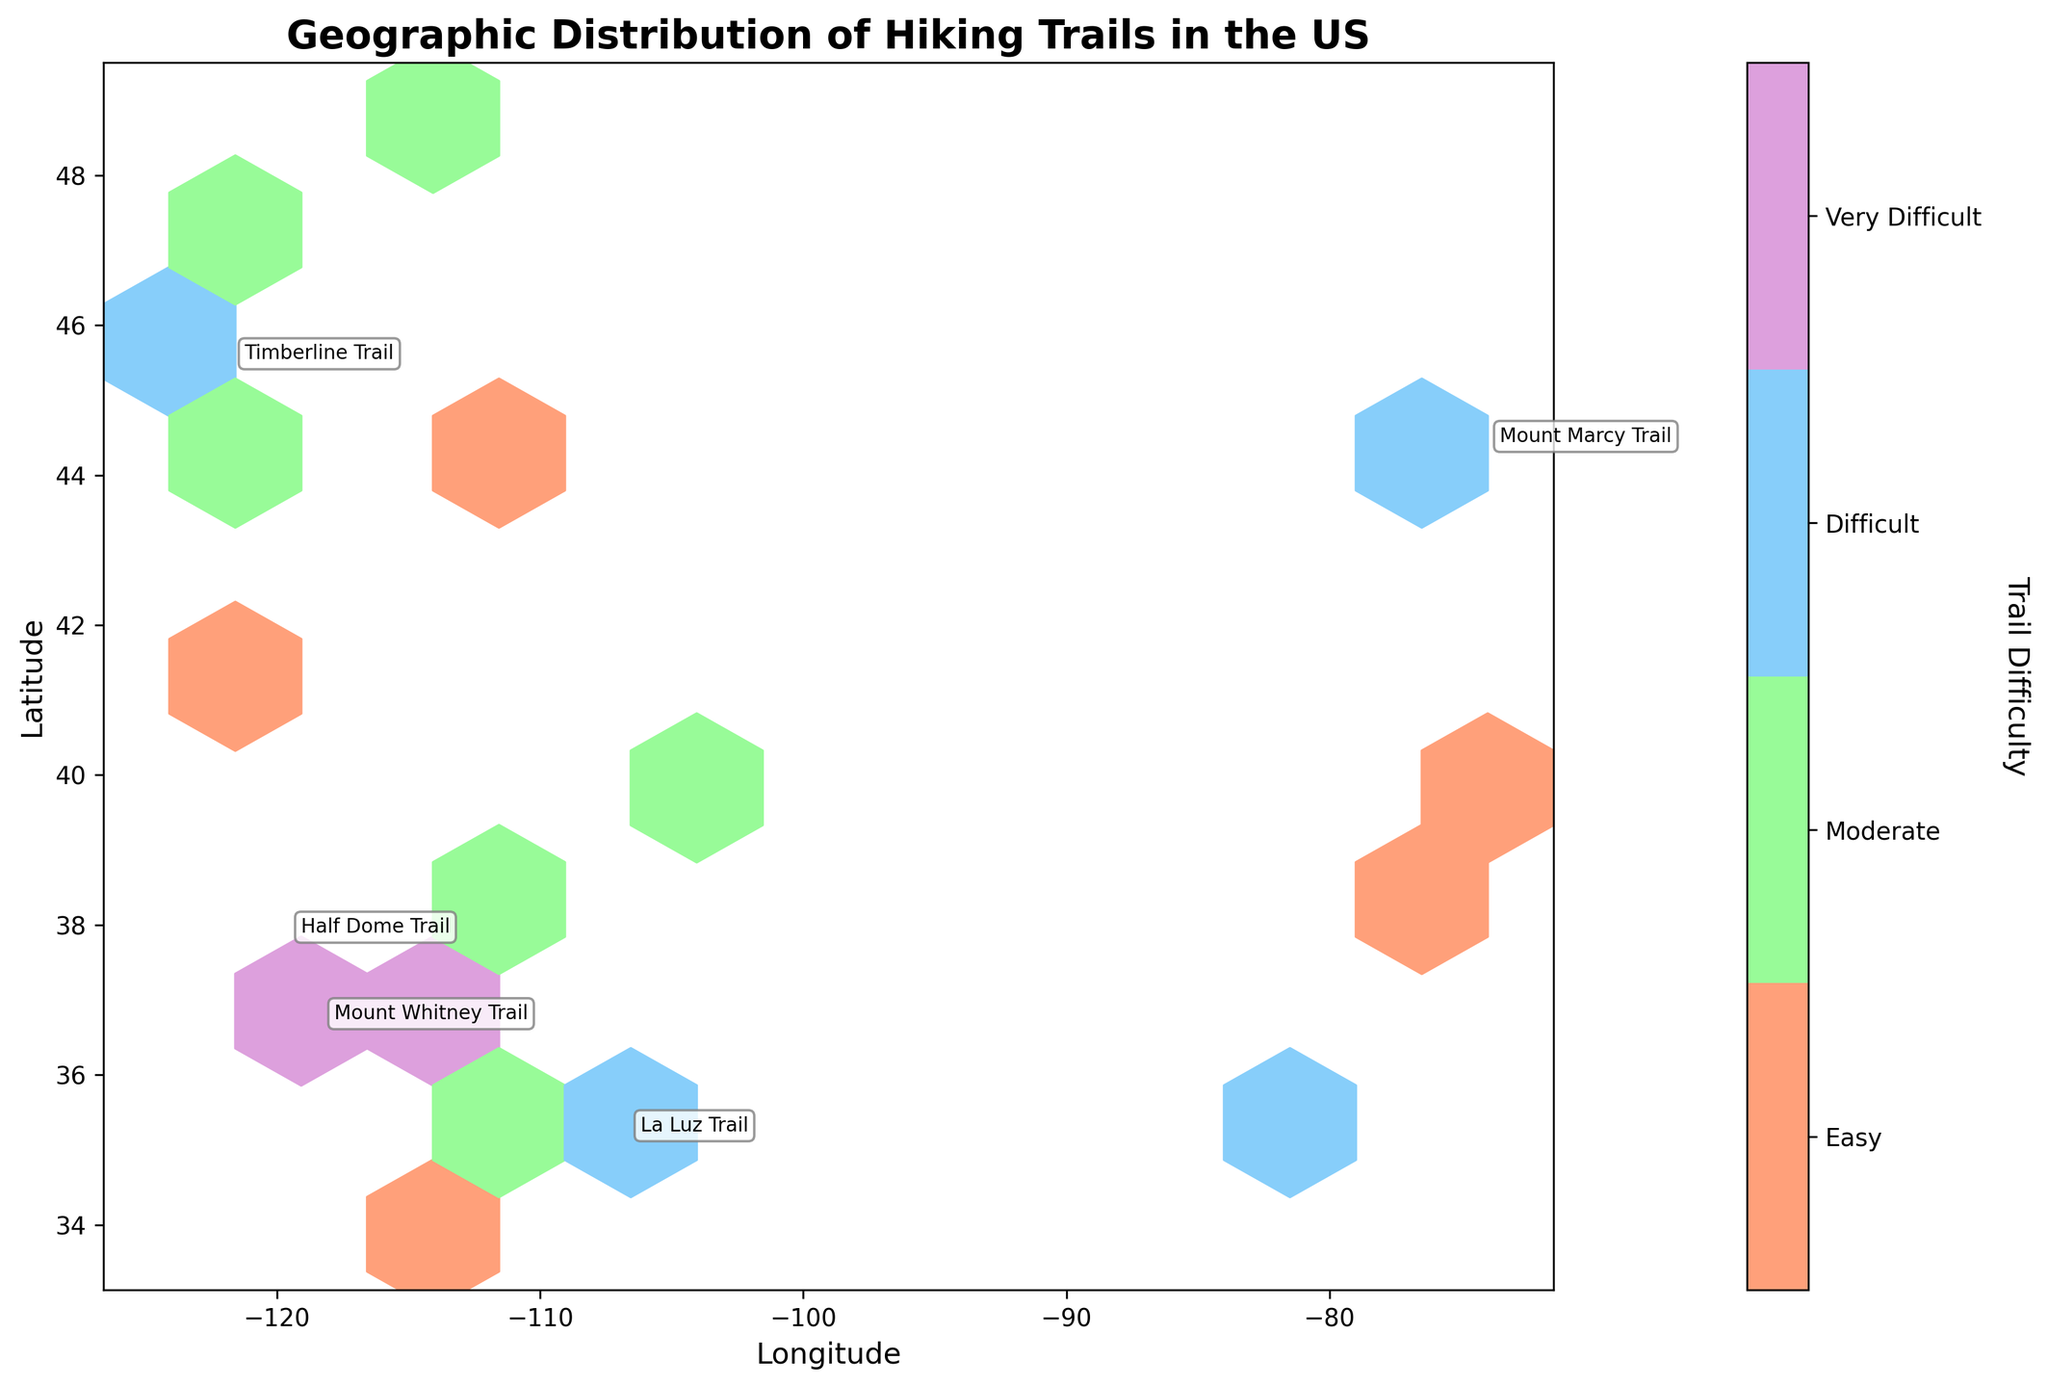What is the title of the plot? The plot’s title is located at the top center of the figure, displayed in a bold format. It reads "Geographic Distribution of Hiking Trails in the US".
Answer: Geographic Distribution of Hiking Trails in the US How are trail difficulties represented in the plot? Trail difficulties are represented by different colors in the plot. According to the color bar on the right, 'Easy' trails are in light orange, 'Moderate' trails are in light green, 'Difficult' trails are in light blue, and 'Very Difficult' trails are in light purple.
Answer: By different colors Which axis represents Longitude? Longitude is displayed on the horizontal axis at the bottom of the figure, labeled as 'Longitude'.
Answer: Horizontal axis Which sections of the US have the most trails with large elevation changes? By examining the annotations and color distribution, we notice clusters of 'Very Difficult' (purple) and 'Difficult' (blue) trails. These are most frequent in the western US, particularly around the Pacific Northwest and central California regions.
Answer: Western US What regions are annotated, and why were they chosen? The annotated regions are those with substantial elevation changes, marking trails like Mount Whitney, Half Dome, La Luz, Angels Landing, and Timberline. These annotations highlight trails with large physical demands.
Answer: Regions with large elevation changes Which has more annotations, the western or eastern US? Observing the annotated points on the plot, the western US has more annotations highlighting trails with significant elevation changes compared to the eastern US.
Answer: Western US Are there more 'Moderate' or 'Easy' trails marked on the plot? By comparing the number of light green hexagons (moderate) vs. light orange hexagons (easy), we see that the plot contains a higher density of 'Moderate' trails.
Answer: Moderate trails Between 'Moderate' and 'Very Difficult' trails, which has a higher elevation change on average? We see that annotations for large elevation changes often correspond with 'Very Difficult' trails in purple. 'Very Difficult' trails like Mount Whitney and Half Dome indicate much higher elevation changes than most 'Moderate' trails.
Answer: Very Difficult trails Which trail has the highest elevation change noted in the annotations? By checking the values next to the annotations, Mount Whitney Trail has the highest noted elevation change at 6100 feet.
Answer: Mount Whitney Trail Is there a noticeable geographical clustering of any specific trail difficulty? Indeed, clusters of specific difficulties are evident. 'Very Difficult' trails (purple) are clustered westward, particularly near California and the Pacific Northwest, showing regional variance in trail difficulty.
Answer: Yes 